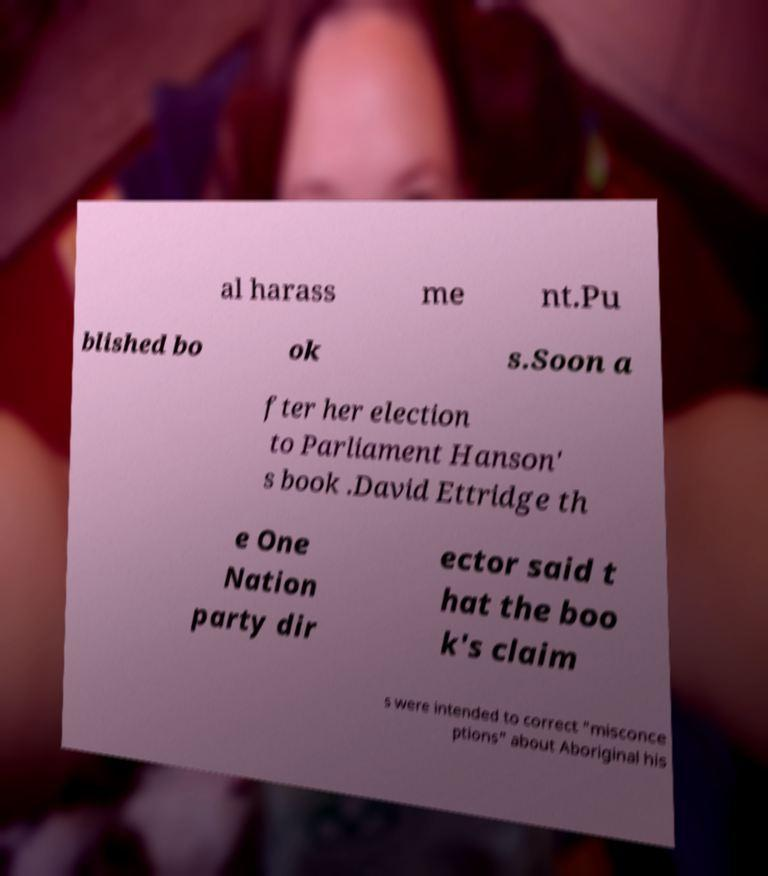Can you accurately transcribe the text from the provided image for me? al harass me nt.Pu blished bo ok s.Soon a fter her election to Parliament Hanson' s book .David Ettridge th e One Nation party dir ector said t hat the boo k's claim s were intended to correct "misconce ptions" about Aboriginal his 